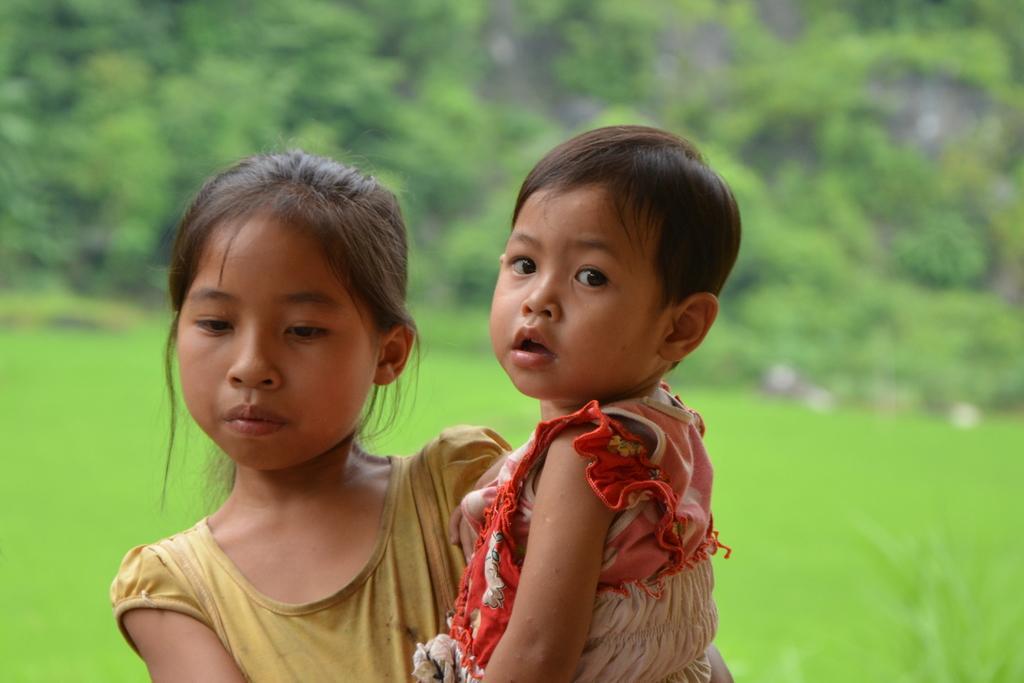Could you give a brief overview of what you see in this image? In this picture I can see a girl holding baby, behind there are some grass and trees. 